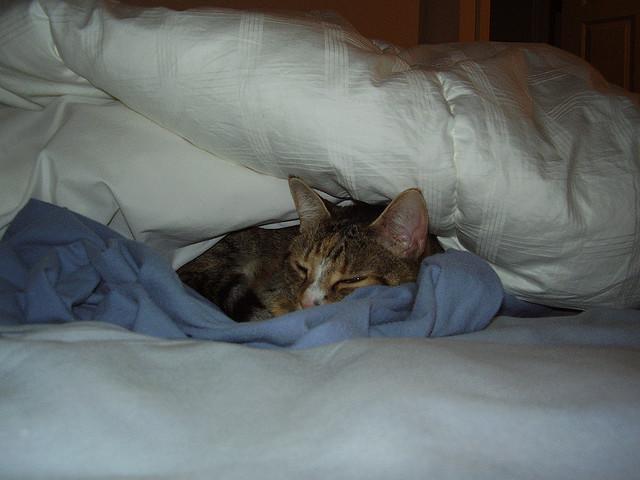Is the animal a baby?
Quick response, please. No. What furniture is the cat on?
Be succinct. Bed. What room of the house was this picture taken in?
Short answer required. Bedroom. What kind of cat is this?
Concise answer only. Tabby. Is the cat asleep?
Keep it brief. Yes. 